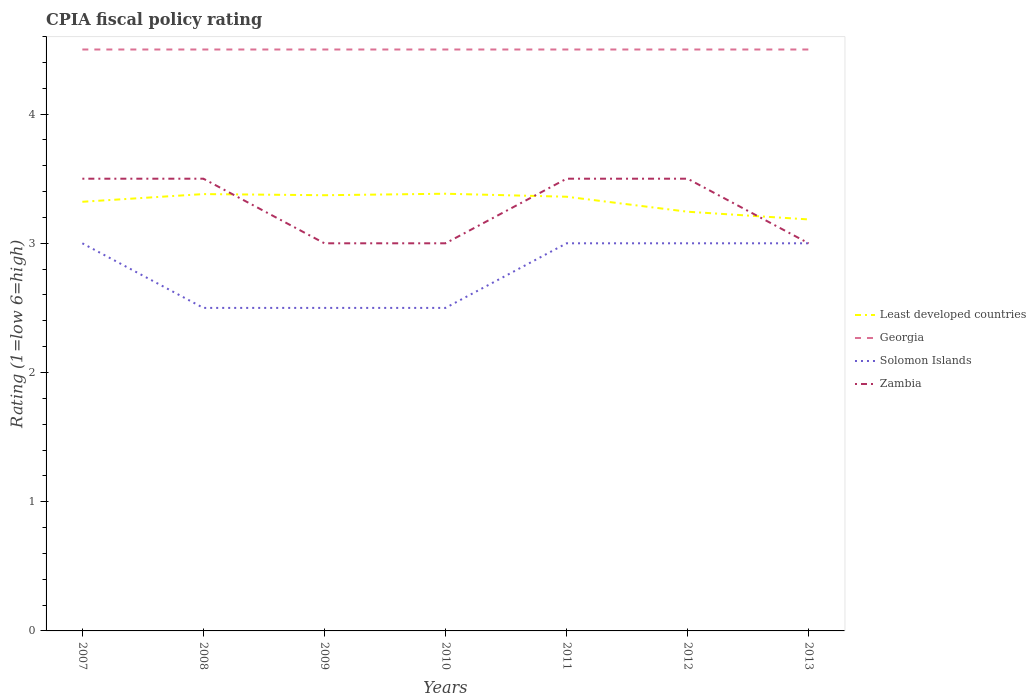How many different coloured lines are there?
Offer a terse response. 4. Does the line corresponding to Zambia intersect with the line corresponding to Georgia?
Make the answer very short. No. Is the number of lines equal to the number of legend labels?
Your answer should be very brief. Yes. Across all years, what is the maximum CPIA rating in Least developed countries?
Ensure brevity in your answer.  3.18. What is the difference between the highest and the second highest CPIA rating in Least developed countries?
Keep it short and to the point. 0.2. Is the CPIA rating in Zambia strictly greater than the CPIA rating in Georgia over the years?
Ensure brevity in your answer.  Yes. How many lines are there?
Provide a short and direct response. 4. What is the difference between two consecutive major ticks on the Y-axis?
Your answer should be very brief. 1. Are the values on the major ticks of Y-axis written in scientific E-notation?
Your answer should be compact. No. Does the graph contain any zero values?
Make the answer very short. No. Does the graph contain grids?
Provide a succinct answer. No. What is the title of the graph?
Your answer should be very brief. CPIA fiscal policy rating. What is the label or title of the Y-axis?
Make the answer very short. Rating (1=low 6=high). What is the Rating (1=low 6=high) of Least developed countries in 2007?
Offer a very short reply. 3.32. What is the Rating (1=low 6=high) of Georgia in 2007?
Your answer should be compact. 4.5. What is the Rating (1=low 6=high) of Solomon Islands in 2007?
Offer a terse response. 3. What is the Rating (1=low 6=high) in Least developed countries in 2008?
Ensure brevity in your answer.  3.38. What is the Rating (1=low 6=high) of Georgia in 2008?
Offer a terse response. 4.5. What is the Rating (1=low 6=high) in Solomon Islands in 2008?
Provide a succinct answer. 2.5. What is the Rating (1=low 6=high) in Zambia in 2008?
Offer a terse response. 3.5. What is the Rating (1=low 6=high) in Least developed countries in 2009?
Your answer should be very brief. 3.37. What is the Rating (1=low 6=high) in Solomon Islands in 2009?
Provide a succinct answer. 2.5. What is the Rating (1=low 6=high) of Least developed countries in 2010?
Give a very brief answer. 3.38. What is the Rating (1=low 6=high) in Georgia in 2010?
Your response must be concise. 4.5. What is the Rating (1=low 6=high) in Zambia in 2010?
Your answer should be compact. 3. What is the Rating (1=low 6=high) of Least developed countries in 2011?
Your answer should be compact. 3.36. What is the Rating (1=low 6=high) of Georgia in 2011?
Your answer should be very brief. 4.5. What is the Rating (1=low 6=high) of Zambia in 2011?
Provide a succinct answer. 3.5. What is the Rating (1=low 6=high) of Least developed countries in 2012?
Provide a succinct answer. 3.24. What is the Rating (1=low 6=high) in Solomon Islands in 2012?
Provide a succinct answer. 3. What is the Rating (1=low 6=high) in Zambia in 2012?
Your response must be concise. 3.5. What is the Rating (1=low 6=high) in Least developed countries in 2013?
Make the answer very short. 3.18. What is the Rating (1=low 6=high) in Zambia in 2013?
Your response must be concise. 3. Across all years, what is the maximum Rating (1=low 6=high) of Least developed countries?
Provide a succinct answer. 3.38. Across all years, what is the maximum Rating (1=low 6=high) of Georgia?
Your response must be concise. 4.5. Across all years, what is the minimum Rating (1=low 6=high) in Least developed countries?
Your answer should be compact. 3.18. Across all years, what is the minimum Rating (1=low 6=high) in Georgia?
Your answer should be compact. 4.5. Across all years, what is the minimum Rating (1=low 6=high) in Zambia?
Make the answer very short. 3. What is the total Rating (1=low 6=high) in Least developed countries in the graph?
Provide a succinct answer. 23.25. What is the total Rating (1=low 6=high) in Georgia in the graph?
Your response must be concise. 31.5. What is the total Rating (1=low 6=high) in Solomon Islands in the graph?
Offer a terse response. 19.5. What is the difference between the Rating (1=low 6=high) of Least developed countries in 2007 and that in 2008?
Keep it short and to the point. -0.06. What is the difference between the Rating (1=low 6=high) in Least developed countries in 2007 and that in 2009?
Make the answer very short. -0.05. What is the difference between the Rating (1=low 6=high) in Georgia in 2007 and that in 2009?
Provide a short and direct response. 0. What is the difference between the Rating (1=low 6=high) in Solomon Islands in 2007 and that in 2009?
Give a very brief answer. 0.5. What is the difference between the Rating (1=low 6=high) of Least developed countries in 2007 and that in 2010?
Make the answer very short. -0.06. What is the difference between the Rating (1=low 6=high) of Solomon Islands in 2007 and that in 2010?
Your response must be concise. 0.5. What is the difference between the Rating (1=low 6=high) of Zambia in 2007 and that in 2010?
Make the answer very short. 0.5. What is the difference between the Rating (1=low 6=high) in Least developed countries in 2007 and that in 2011?
Provide a short and direct response. -0.04. What is the difference between the Rating (1=low 6=high) of Solomon Islands in 2007 and that in 2011?
Your answer should be very brief. 0. What is the difference between the Rating (1=low 6=high) of Zambia in 2007 and that in 2011?
Give a very brief answer. 0. What is the difference between the Rating (1=low 6=high) in Least developed countries in 2007 and that in 2012?
Keep it short and to the point. 0.08. What is the difference between the Rating (1=low 6=high) of Georgia in 2007 and that in 2012?
Provide a succinct answer. 0. What is the difference between the Rating (1=low 6=high) in Solomon Islands in 2007 and that in 2012?
Your answer should be very brief. 0. What is the difference between the Rating (1=low 6=high) in Zambia in 2007 and that in 2012?
Offer a very short reply. 0. What is the difference between the Rating (1=low 6=high) in Least developed countries in 2007 and that in 2013?
Offer a very short reply. 0.14. What is the difference between the Rating (1=low 6=high) of Solomon Islands in 2007 and that in 2013?
Give a very brief answer. 0. What is the difference between the Rating (1=low 6=high) in Least developed countries in 2008 and that in 2009?
Provide a succinct answer. 0.01. What is the difference between the Rating (1=low 6=high) in Solomon Islands in 2008 and that in 2009?
Make the answer very short. 0. What is the difference between the Rating (1=low 6=high) in Least developed countries in 2008 and that in 2010?
Offer a very short reply. -0. What is the difference between the Rating (1=low 6=high) of Georgia in 2008 and that in 2010?
Your answer should be very brief. 0. What is the difference between the Rating (1=low 6=high) of Zambia in 2008 and that in 2010?
Offer a very short reply. 0.5. What is the difference between the Rating (1=low 6=high) in Least developed countries in 2008 and that in 2011?
Offer a very short reply. 0.02. What is the difference between the Rating (1=low 6=high) in Georgia in 2008 and that in 2011?
Give a very brief answer. 0. What is the difference between the Rating (1=low 6=high) in Solomon Islands in 2008 and that in 2011?
Keep it short and to the point. -0.5. What is the difference between the Rating (1=low 6=high) in Least developed countries in 2008 and that in 2012?
Provide a short and direct response. 0.14. What is the difference between the Rating (1=low 6=high) of Solomon Islands in 2008 and that in 2012?
Your answer should be very brief. -0.5. What is the difference between the Rating (1=low 6=high) in Least developed countries in 2008 and that in 2013?
Make the answer very short. 0.2. What is the difference between the Rating (1=low 6=high) in Georgia in 2008 and that in 2013?
Ensure brevity in your answer.  0. What is the difference between the Rating (1=low 6=high) of Least developed countries in 2009 and that in 2010?
Give a very brief answer. -0.01. What is the difference between the Rating (1=low 6=high) of Georgia in 2009 and that in 2010?
Give a very brief answer. 0. What is the difference between the Rating (1=low 6=high) of Zambia in 2009 and that in 2010?
Your answer should be compact. 0. What is the difference between the Rating (1=low 6=high) in Least developed countries in 2009 and that in 2011?
Offer a terse response. 0.01. What is the difference between the Rating (1=low 6=high) of Solomon Islands in 2009 and that in 2011?
Offer a very short reply. -0.5. What is the difference between the Rating (1=low 6=high) of Zambia in 2009 and that in 2011?
Your answer should be very brief. -0.5. What is the difference between the Rating (1=low 6=high) in Least developed countries in 2009 and that in 2012?
Keep it short and to the point. 0.13. What is the difference between the Rating (1=low 6=high) of Georgia in 2009 and that in 2012?
Give a very brief answer. 0. What is the difference between the Rating (1=low 6=high) in Solomon Islands in 2009 and that in 2012?
Your answer should be compact. -0.5. What is the difference between the Rating (1=low 6=high) in Least developed countries in 2009 and that in 2013?
Keep it short and to the point. 0.19. What is the difference between the Rating (1=low 6=high) of Georgia in 2009 and that in 2013?
Give a very brief answer. 0. What is the difference between the Rating (1=low 6=high) of Zambia in 2009 and that in 2013?
Keep it short and to the point. 0. What is the difference between the Rating (1=low 6=high) of Least developed countries in 2010 and that in 2011?
Offer a terse response. 0.02. What is the difference between the Rating (1=low 6=high) of Georgia in 2010 and that in 2011?
Ensure brevity in your answer.  0. What is the difference between the Rating (1=low 6=high) in Least developed countries in 2010 and that in 2012?
Provide a succinct answer. 0.14. What is the difference between the Rating (1=low 6=high) in Zambia in 2010 and that in 2012?
Give a very brief answer. -0.5. What is the difference between the Rating (1=low 6=high) of Least developed countries in 2010 and that in 2013?
Your answer should be very brief. 0.2. What is the difference between the Rating (1=low 6=high) of Georgia in 2010 and that in 2013?
Keep it short and to the point. 0. What is the difference between the Rating (1=low 6=high) in Least developed countries in 2011 and that in 2012?
Keep it short and to the point. 0.12. What is the difference between the Rating (1=low 6=high) in Georgia in 2011 and that in 2012?
Your answer should be very brief. 0. What is the difference between the Rating (1=low 6=high) in Solomon Islands in 2011 and that in 2012?
Provide a succinct answer. 0. What is the difference between the Rating (1=low 6=high) in Least developed countries in 2011 and that in 2013?
Your answer should be compact. 0.18. What is the difference between the Rating (1=low 6=high) in Solomon Islands in 2011 and that in 2013?
Provide a short and direct response. 0. What is the difference between the Rating (1=low 6=high) of Zambia in 2011 and that in 2013?
Your answer should be very brief. 0.5. What is the difference between the Rating (1=low 6=high) in Least developed countries in 2012 and that in 2013?
Make the answer very short. 0.06. What is the difference between the Rating (1=low 6=high) in Georgia in 2012 and that in 2013?
Ensure brevity in your answer.  0. What is the difference between the Rating (1=low 6=high) of Zambia in 2012 and that in 2013?
Provide a succinct answer. 0.5. What is the difference between the Rating (1=low 6=high) in Least developed countries in 2007 and the Rating (1=low 6=high) in Georgia in 2008?
Your answer should be compact. -1.18. What is the difference between the Rating (1=low 6=high) in Least developed countries in 2007 and the Rating (1=low 6=high) in Solomon Islands in 2008?
Offer a very short reply. 0.82. What is the difference between the Rating (1=low 6=high) of Least developed countries in 2007 and the Rating (1=low 6=high) of Zambia in 2008?
Your response must be concise. -0.18. What is the difference between the Rating (1=low 6=high) in Georgia in 2007 and the Rating (1=low 6=high) in Zambia in 2008?
Your answer should be very brief. 1. What is the difference between the Rating (1=low 6=high) of Least developed countries in 2007 and the Rating (1=low 6=high) of Georgia in 2009?
Keep it short and to the point. -1.18. What is the difference between the Rating (1=low 6=high) of Least developed countries in 2007 and the Rating (1=low 6=high) of Solomon Islands in 2009?
Your answer should be compact. 0.82. What is the difference between the Rating (1=low 6=high) in Least developed countries in 2007 and the Rating (1=low 6=high) in Zambia in 2009?
Your response must be concise. 0.32. What is the difference between the Rating (1=low 6=high) of Georgia in 2007 and the Rating (1=low 6=high) of Solomon Islands in 2009?
Provide a succinct answer. 2. What is the difference between the Rating (1=low 6=high) in Georgia in 2007 and the Rating (1=low 6=high) in Zambia in 2009?
Make the answer very short. 1.5. What is the difference between the Rating (1=low 6=high) in Least developed countries in 2007 and the Rating (1=low 6=high) in Georgia in 2010?
Offer a terse response. -1.18. What is the difference between the Rating (1=low 6=high) in Least developed countries in 2007 and the Rating (1=low 6=high) in Solomon Islands in 2010?
Ensure brevity in your answer.  0.82. What is the difference between the Rating (1=low 6=high) in Least developed countries in 2007 and the Rating (1=low 6=high) in Zambia in 2010?
Your answer should be compact. 0.32. What is the difference between the Rating (1=low 6=high) of Georgia in 2007 and the Rating (1=low 6=high) of Solomon Islands in 2010?
Make the answer very short. 2. What is the difference between the Rating (1=low 6=high) in Georgia in 2007 and the Rating (1=low 6=high) in Zambia in 2010?
Provide a short and direct response. 1.5. What is the difference between the Rating (1=low 6=high) of Least developed countries in 2007 and the Rating (1=low 6=high) of Georgia in 2011?
Your response must be concise. -1.18. What is the difference between the Rating (1=low 6=high) in Least developed countries in 2007 and the Rating (1=low 6=high) in Solomon Islands in 2011?
Offer a terse response. 0.32. What is the difference between the Rating (1=low 6=high) of Least developed countries in 2007 and the Rating (1=low 6=high) of Zambia in 2011?
Make the answer very short. -0.18. What is the difference between the Rating (1=low 6=high) of Solomon Islands in 2007 and the Rating (1=low 6=high) of Zambia in 2011?
Provide a succinct answer. -0.5. What is the difference between the Rating (1=low 6=high) in Least developed countries in 2007 and the Rating (1=low 6=high) in Georgia in 2012?
Your answer should be compact. -1.18. What is the difference between the Rating (1=low 6=high) of Least developed countries in 2007 and the Rating (1=low 6=high) of Solomon Islands in 2012?
Provide a short and direct response. 0.32. What is the difference between the Rating (1=low 6=high) in Least developed countries in 2007 and the Rating (1=low 6=high) in Zambia in 2012?
Offer a terse response. -0.18. What is the difference between the Rating (1=low 6=high) of Georgia in 2007 and the Rating (1=low 6=high) of Zambia in 2012?
Give a very brief answer. 1. What is the difference between the Rating (1=low 6=high) of Solomon Islands in 2007 and the Rating (1=low 6=high) of Zambia in 2012?
Your response must be concise. -0.5. What is the difference between the Rating (1=low 6=high) of Least developed countries in 2007 and the Rating (1=low 6=high) of Georgia in 2013?
Make the answer very short. -1.18. What is the difference between the Rating (1=low 6=high) of Least developed countries in 2007 and the Rating (1=low 6=high) of Solomon Islands in 2013?
Your answer should be compact. 0.32. What is the difference between the Rating (1=low 6=high) in Least developed countries in 2007 and the Rating (1=low 6=high) in Zambia in 2013?
Keep it short and to the point. 0.32. What is the difference between the Rating (1=low 6=high) in Georgia in 2007 and the Rating (1=low 6=high) in Solomon Islands in 2013?
Provide a short and direct response. 1.5. What is the difference between the Rating (1=low 6=high) in Least developed countries in 2008 and the Rating (1=low 6=high) in Georgia in 2009?
Your answer should be very brief. -1.12. What is the difference between the Rating (1=low 6=high) in Least developed countries in 2008 and the Rating (1=low 6=high) in Solomon Islands in 2009?
Ensure brevity in your answer.  0.88. What is the difference between the Rating (1=low 6=high) in Least developed countries in 2008 and the Rating (1=low 6=high) in Zambia in 2009?
Offer a terse response. 0.38. What is the difference between the Rating (1=low 6=high) in Georgia in 2008 and the Rating (1=low 6=high) in Solomon Islands in 2009?
Ensure brevity in your answer.  2. What is the difference between the Rating (1=low 6=high) of Solomon Islands in 2008 and the Rating (1=low 6=high) of Zambia in 2009?
Make the answer very short. -0.5. What is the difference between the Rating (1=low 6=high) in Least developed countries in 2008 and the Rating (1=low 6=high) in Georgia in 2010?
Your answer should be compact. -1.12. What is the difference between the Rating (1=low 6=high) of Least developed countries in 2008 and the Rating (1=low 6=high) of Solomon Islands in 2010?
Your answer should be compact. 0.88. What is the difference between the Rating (1=low 6=high) of Least developed countries in 2008 and the Rating (1=low 6=high) of Zambia in 2010?
Ensure brevity in your answer.  0.38. What is the difference between the Rating (1=low 6=high) in Georgia in 2008 and the Rating (1=low 6=high) in Solomon Islands in 2010?
Ensure brevity in your answer.  2. What is the difference between the Rating (1=low 6=high) of Least developed countries in 2008 and the Rating (1=low 6=high) of Georgia in 2011?
Provide a succinct answer. -1.12. What is the difference between the Rating (1=low 6=high) of Least developed countries in 2008 and the Rating (1=low 6=high) of Solomon Islands in 2011?
Make the answer very short. 0.38. What is the difference between the Rating (1=low 6=high) of Least developed countries in 2008 and the Rating (1=low 6=high) of Zambia in 2011?
Provide a succinct answer. -0.12. What is the difference between the Rating (1=low 6=high) of Georgia in 2008 and the Rating (1=low 6=high) of Solomon Islands in 2011?
Offer a terse response. 1.5. What is the difference between the Rating (1=low 6=high) in Solomon Islands in 2008 and the Rating (1=low 6=high) in Zambia in 2011?
Your answer should be compact. -1. What is the difference between the Rating (1=low 6=high) in Least developed countries in 2008 and the Rating (1=low 6=high) in Georgia in 2012?
Provide a short and direct response. -1.12. What is the difference between the Rating (1=low 6=high) of Least developed countries in 2008 and the Rating (1=low 6=high) of Solomon Islands in 2012?
Give a very brief answer. 0.38. What is the difference between the Rating (1=low 6=high) in Least developed countries in 2008 and the Rating (1=low 6=high) in Zambia in 2012?
Provide a succinct answer. -0.12. What is the difference between the Rating (1=low 6=high) of Solomon Islands in 2008 and the Rating (1=low 6=high) of Zambia in 2012?
Offer a very short reply. -1. What is the difference between the Rating (1=low 6=high) of Least developed countries in 2008 and the Rating (1=low 6=high) of Georgia in 2013?
Your answer should be very brief. -1.12. What is the difference between the Rating (1=low 6=high) in Least developed countries in 2008 and the Rating (1=low 6=high) in Solomon Islands in 2013?
Provide a succinct answer. 0.38. What is the difference between the Rating (1=low 6=high) of Least developed countries in 2008 and the Rating (1=low 6=high) of Zambia in 2013?
Your answer should be compact. 0.38. What is the difference between the Rating (1=low 6=high) in Georgia in 2008 and the Rating (1=low 6=high) in Solomon Islands in 2013?
Keep it short and to the point. 1.5. What is the difference between the Rating (1=low 6=high) of Solomon Islands in 2008 and the Rating (1=low 6=high) of Zambia in 2013?
Provide a short and direct response. -0.5. What is the difference between the Rating (1=low 6=high) of Least developed countries in 2009 and the Rating (1=low 6=high) of Georgia in 2010?
Keep it short and to the point. -1.13. What is the difference between the Rating (1=low 6=high) of Least developed countries in 2009 and the Rating (1=low 6=high) of Solomon Islands in 2010?
Offer a terse response. 0.87. What is the difference between the Rating (1=low 6=high) in Least developed countries in 2009 and the Rating (1=low 6=high) in Zambia in 2010?
Your answer should be very brief. 0.37. What is the difference between the Rating (1=low 6=high) of Georgia in 2009 and the Rating (1=low 6=high) of Solomon Islands in 2010?
Your answer should be very brief. 2. What is the difference between the Rating (1=low 6=high) in Solomon Islands in 2009 and the Rating (1=low 6=high) in Zambia in 2010?
Offer a very short reply. -0.5. What is the difference between the Rating (1=low 6=high) of Least developed countries in 2009 and the Rating (1=low 6=high) of Georgia in 2011?
Your answer should be very brief. -1.13. What is the difference between the Rating (1=low 6=high) of Least developed countries in 2009 and the Rating (1=low 6=high) of Solomon Islands in 2011?
Ensure brevity in your answer.  0.37. What is the difference between the Rating (1=low 6=high) in Least developed countries in 2009 and the Rating (1=low 6=high) in Zambia in 2011?
Your answer should be compact. -0.13. What is the difference between the Rating (1=low 6=high) of Least developed countries in 2009 and the Rating (1=low 6=high) of Georgia in 2012?
Offer a very short reply. -1.13. What is the difference between the Rating (1=low 6=high) of Least developed countries in 2009 and the Rating (1=low 6=high) of Solomon Islands in 2012?
Offer a very short reply. 0.37. What is the difference between the Rating (1=low 6=high) in Least developed countries in 2009 and the Rating (1=low 6=high) in Zambia in 2012?
Ensure brevity in your answer.  -0.13. What is the difference between the Rating (1=low 6=high) in Georgia in 2009 and the Rating (1=low 6=high) in Solomon Islands in 2012?
Make the answer very short. 1.5. What is the difference between the Rating (1=low 6=high) of Solomon Islands in 2009 and the Rating (1=low 6=high) of Zambia in 2012?
Offer a very short reply. -1. What is the difference between the Rating (1=low 6=high) in Least developed countries in 2009 and the Rating (1=low 6=high) in Georgia in 2013?
Provide a short and direct response. -1.13. What is the difference between the Rating (1=low 6=high) of Least developed countries in 2009 and the Rating (1=low 6=high) of Solomon Islands in 2013?
Provide a succinct answer. 0.37. What is the difference between the Rating (1=low 6=high) in Least developed countries in 2009 and the Rating (1=low 6=high) in Zambia in 2013?
Provide a succinct answer. 0.37. What is the difference between the Rating (1=low 6=high) in Georgia in 2009 and the Rating (1=low 6=high) in Zambia in 2013?
Provide a succinct answer. 1.5. What is the difference between the Rating (1=low 6=high) in Least developed countries in 2010 and the Rating (1=low 6=high) in Georgia in 2011?
Your answer should be very brief. -1.12. What is the difference between the Rating (1=low 6=high) of Least developed countries in 2010 and the Rating (1=low 6=high) of Solomon Islands in 2011?
Your response must be concise. 0.38. What is the difference between the Rating (1=low 6=high) in Least developed countries in 2010 and the Rating (1=low 6=high) in Zambia in 2011?
Ensure brevity in your answer.  -0.12. What is the difference between the Rating (1=low 6=high) of Solomon Islands in 2010 and the Rating (1=low 6=high) of Zambia in 2011?
Your answer should be compact. -1. What is the difference between the Rating (1=low 6=high) of Least developed countries in 2010 and the Rating (1=low 6=high) of Georgia in 2012?
Provide a short and direct response. -1.12. What is the difference between the Rating (1=low 6=high) of Least developed countries in 2010 and the Rating (1=low 6=high) of Solomon Islands in 2012?
Your answer should be compact. 0.38. What is the difference between the Rating (1=low 6=high) in Least developed countries in 2010 and the Rating (1=low 6=high) in Zambia in 2012?
Provide a short and direct response. -0.12. What is the difference between the Rating (1=low 6=high) in Least developed countries in 2010 and the Rating (1=low 6=high) in Georgia in 2013?
Your answer should be compact. -1.12. What is the difference between the Rating (1=low 6=high) in Least developed countries in 2010 and the Rating (1=low 6=high) in Solomon Islands in 2013?
Offer a very short reply. 0.38. What is the difference between the Rating (1=low 6=high) in Least developed countries in 2010 and the Rating (1=low 6=high) in Zambia in 2013?
Offer a terse response. 0.38. What is the difference between the Rating (1=low 6=high) of Georgia in 2010 and the Rating (1=low 6=high) of Zambia in 2013?
Provide a short and direct response. 1.5. What is the difference between the Rating (1=low 6=high) in Least developed countries in 2011 and the Rating (1=low 6=high) in Georgia in 2012?
Provide a succinct answer. -1.14. What is the difference between the Rating (1=low 6=high) in Least developed countries in 2011 and the Rating (1=low 6=high) in Solomon Islands in 2012?
Your answer should be very brief. 0.36. What is the difference between the Rating (1=low 6=high) of Least developed countries in 2011 and the Rating (1=low 6=high) of Zambia in 2012?
Your answer should be very brief. -0.14. What is the difference between the Rating (1=low 6=high) of Least developed countries in 2011 and the Rating (1=low 6=high) of Georgia in 2013?
Give a very brief answer. -1.14. What is the difference between the Rating (1=low 6=high) in Least developed countries in 2011 and the Rating (1=low 6=high) in Solomon Islands in 2013?
Keep it short and to the point. 0.36. What is the difference between the Rating (1=low 6=high) in Least developed countries in 2011 and the Rating (1=low 6=high) in Zambia in 2013?
Provide a short and direct response. 0.36. What is the difference between the Rating (1=low 6=high) of Georgia in 2011 and the Rating (1=low 6=high) of Zambia in 2013?
Ensure brevity in your answer.  1.5. What is the difference between the Rating (1=low 6=high) of Least developed countries in 2012 and the Rating (1=low 6=high) of Georgia in 2013?
Offer a very short reply. -1.26. What is the difference between the Rating (1=low 6=high) of Least developed countries in 2012 and the Rating (1=low 6=high) of Solomon Islands in 2013?
Make the answer very short. 0.24. What is the difference between the Rating (1=low 6=high) in Least developed countries in 2012 and the Rating (1=low 6=high) in Zambia in 2013?
Ensure brevity in your answer.  0.24. What is the average Rating (1=low 6=high) of Least developed countries per year?
Provide a succinct answer. 3.32. What is the average Rating (1=low 6=high) of Georgia per year?
Keep it short and to the point. 4.5. What is the average Rating (1=low 6=high) in Solomon Islands per year?
Your answer should be very brief. 2.79. What is the average Rating (1=low 6=high) of Zambia per year?
Your response must be concise. 3.29. In the year 2007, what is the difference between the Rating (1=low 6=high) of Least developed countries and Rating (1=low 6=high) of Georgia?
Your answer should be very brief. -1.18. In the year 2007, what is the difference between the Rating (1=low 6=high) of Least developed countries and Rating (1=low 6=high) of Solomon Islands?
Provide a succinct answer. 0.32. In the year 2007, what is the difference between the Rating (1=low 6=high) in Least developed countries and Rating (1=low 6=high) in Zambia?
Make the answer very short. -0.18. In the year 2007, what is the difference between the Rating (1=low 6=high) in Georgia and Rating (1=low 6=high) in Solomon Islands?
Provide a succinct answer. 1.5. In the year 2008, what is the difference between the Rating (1=low 6=high) in Least developed countries and Rating (1=low 6=high) in Georgia?
Offer a very short reply. -1.12. In the year 2008, what is the difference between the Rating (1=low 6=high) in Least developed countries and Rating (1=low 6=high) in Solomon Islands?
Provide a succinct answer. 0.88. In the year 2008, what is the difference between the Rating (1=low 6=high) in Least developed countries and Rating (1=low 6=high) in Zambia?
Your response must be concise. -0.12. In the year 2008, what is the difference between the Rating (1=low 6=high) of Solomon Islands and Rating (1=low 6=high) of Zambia?
Provide a succinct answer. -1. In the year 2009, what is the difference between the Rating (1=low 6=high) of Least developed countries and Rating (1=low 6=high) of Georgia?
Keep it short and to the point. -1.13. In the year 2009, what is the difference between the Rating (1=low 6=high) of Least developed countries and Rating (1=low 6=high) of Solomon Islands?
Give a very brief answer. 0.87. In the year 2009, what is the difference between the Rating (1=low 6=high) of Least developed countries and Rating (1=low 6=high) of Zambia?
Your answer should be very brief. 0.37. In the year 2010, what is the difference between the Rating (1=low 6=high) in Least developed countries and Rating (1=low 6=high) in Georgia?
Your answer should be very brief. -1.12. In the year 2010, what is the difference between the Rating (1=low 6=high) in Least developed countries and Rating (1=low 6=high) in Solomon Islands?
Ensure brevity in your answer.  0.88. In the year 2010, what is the difference between the Rating (1=low 6=high) of Least developed countries and Rating (1=low 6=high) of Zambia?
Your answer should be very brief. 0.38. In the year 2010, what is the difference between the Rating (1=low 6=high) of Georgia and Rating (1=low 6=high) of Zambia?
Your answer should be compact. 1.5. In the year 2010, what is the difference between the Rating (1=low 6=high) of Solomon Islands and Rating (1=low 6=high) of Zambia?
Your answer should be very brief. -0.5. In the year 2011, what is the difference between the Rating (1=low 6=high) of Least developed countries and Rating (1=low 6=high) of Georgia?
Provide a short and direct response. -1.14. In the year 2011, what is the difference between the Rating (1=low 6=high) of Least developed countries and Rating (1=low 6=high) of Solomon Islands?
Your answer should be very brief. 0.36. In the year 2011, what is the difference between the Rating (1=low 6=high) in Least developed countries and Rating (1=low 6=high) in Zambia?
Make the answer very short. -0.14. In the year 2011, what is the difference between the Rating (1=low 6=high) in Solomon Islands and Rating (1=low 6=high) in Zambia?
Keep it short and to the point. -0.5. In the year 2012, what is the difference between the Rating (1=low 6=high) in Least developed countries and Rating (1=low 6=high) in Georgia?
Ensure brevity in your answer.  -1.26. In the year 2012, what is the difference between the Rating (1=low 6=high) of Least developed countries and Rating (1=low 6=high) of Solomon Islands?
Ensure brevity in your answer.  0.24. In the year 2012, what is the difference between the Rating (1=low 6=high) of Least developed countries and Rating (1=low 6=high) of Zambia?
Provide a short and direct response. -0.26. In the year 2012, what is the difference between the Rating (1=low 6=high) of Georgia and Rating (1=low 6=high) of Solomon Islands?
Provide a succinct answer. 1.5. In the year 2012, what is the difference between the Rating (1=low 6=high) of Solomon Islands and Rating (1=low 6=high) of Zambia?
Provide a short and direct response. -0.5. In the year 2013, what is the difference between the Rating (1=low 6=high) in Least developed countries and Rating (1=low 6=high) in Georgia?
Ensure brevity in your answer.  -1.32. In the year 2013, what is the difference between the Rating (1=low 6=high) of Least developed countries and Rating (1=low 6=high) of Solomon Islands?
Your answer should be compact. 0.18. In the year 2013, what is the difference between the Rating (1=low 6=high) in Least developed countries and Rating (1=low 6=high) in Zambia?
Your answer should be compact. 0.18. In the year 2013, what is the difference between the Rating (1=low 6=high) in Georgia and Rating (1=low 6=high) in Solomon Islands?
Offer a terse response. 1.5. In the year 2013, what is the difference between the Rating (1=low 6=high) in Georgia and Rating (1=low 6=high) in Zambia?
Keep it short and to the point. 1.5. What is the ratio of the Rating (1=low 6=high) in Least developed countries in 2007 to that in 2008?
Give a very brief answer. 0.98. What is the ratio of the Rating (1=low 6=high) in Solomon Islands in 2007 to that in 2008?
Offer a very short reply. 1.2. What is the ratio of the Rating (1=low 6=high) of Zambia in 2007 to that in 2008?
Give a very brief answer. 1. What is the ratio of the Rating (1=low 6=high) of Georgia in 2007 to that in 2009?
Your response must be concise. 1. What is the ratio of the Rating (1=low 6=high) in Zambia in 2007 to that in 2009?
Ensure brevity in your answer.  1.17. What is the ratio of the Rating (1=low 6=high) in Least developed countries in 2007 to that in 2010?
Your answer should be very brief. 0.98. What is the ratio of the Rating (1=low 6=high) of Georgia in 2007 to that in 2010?
Ensure brevity in your answer.  1. What is the ratio of the Rating (1=low 6=high) of Solomon Islands in 2007 to that in 2010?
Your answer should be very brief. 1.2. What is the ratio of the Rating (1=low 6=high) in Zambia in 2007 to that in 2010?
Your answer should be very brief. 1.17. What is the ratio of the Rating (1=low 6=high) of Least developed countries in 2007 to that in 2011?
Provide a short and direct response. 0.99. What is the ratio of the Rating (1=low 6=high) of Georgia in 2007 to that in 2011?
Your response must be concise. 1. What is the ratio of the Rating (1=low 6=high) of Solomon Islands in 2007 to that in 2011?
Your answer should be compact. 1. What is the ratio of the Rating (1=low 6=high) of Zambia in 2007 to that in 2011?
Make the answer very short. 1. What is the ratio of the Rating (1=low 6=high) in Least developed countries in 2007 to that in 2012?
Provide a short and direct response. 1.02. What is the ratio of the Rating (1=low 6=high) in Georgia in 2007 to that in 2012?
Provide a short and direct response. 1. What is the ratio of the Rating (1=low 6=high) in Solomon Islands in 2007 to that in 2012?
Offer a very short reply. 1. What is the ratio of the Rating (1=low 6=high) in Zambia in 2007 to that in 2012?
Ensure brevity in your answer.  1. What is the ratio of the Rating (1=low 6=high) in Least developed countries in 2007 to that in 2013?
Your answer should be compact. 1.04. What is the ratio of the Rating (1=low 6=high) in Zambia in 2007 to that in 2013?
Your answer should be compact. 1.17. What is the ratio of the Rating (1=low 6=high) of Least developed countries in 2008 to that in 2009?
Keep it short and to the point. 1. What is the ratio of the Rating (1=low 6=high) of Georgia in 2008 to that in 2009?
Provide a succinct answer. 1. What is the ratio of the Rating (1=low 6=high) in Solomon Islands in 2008 to that in 2009?
Keep it short and to the point. 1. What is the ratio of the Rating (1=low 6=high) of Zambia in 2008 to that in 2010?
Your response must be concise. 1.17. What is the ratio of the Rating (1=low 6=high) of Least developed countries in 2008 to that in 2011?
Your response must be concise. 1.01. What is the ratio of the Rating (1=low 6=high) of Georgia in 2008 to that in 2011?
Your answer should be compact. 1. What is the ratio of the Rating (1=low 6=high) in Solomon Islands in 2008 to that in 2011?
Your response must be concise. 0.83. What is the ratio of the Rating (1=low 6=high) of Zambia in 2008 to that in 2011?
Provide a short and direct response. 1. What is the ratio of the Rating (1=low 6=high) of Least developed countries in 2008 to that in 2012?
Keep it short and to the point. 1.04. What is the ratio of the Rating (1=low 6=high) of Least developed countries in 2008 to that in 2013?
Offer a very short reply. 1.06. What is the ratio of the Rating (1=low 6=high) of Zambia in 2008 to that in 2013?
Offer a very short reply. 1.17. What is the ratio of the Rating (1=low 6=high) of Zambia in 2009 to that in 2010?
Give a very brief answer. 1. What is the ratio of the Rating (1=low 6=high) in Least developed countries in 2009 to that in 2011?
Keep it short and to the point. 1. What is the ratio of the Rating (1=low 6=high) in Georgia in 2009 to that in 2011?
Give a very brief answer. 1. What is the ratio of the Rating (1=low 6=high) of Least developed countries in 2009 to that in 2012?
Give a very brief answer. 1.04. What is the ratio of the Rating (1=low 6=high) of Solomon Islands in 2009 to that in 2012?
Offer a terse response. 0.83. What is the ratio of the Rating (1=low 6=high) of Zambia in 2009 to that in 2012?
Your response must be concise. 0.86. What is the ratio of the Rating (1=low 6=high) in Least developed countries in 2009 to that in 2013?
Make the answer very short. 1.06. What is the ratio of the Rating (1=low 6=high) of Solomon Islands in 2009 to that in 2013?
Provide a succinct answer. 0.83. What is the ratio of the Rating (1=low 6=high) of Least developed countries in 2010 to that in 2011?
Provide a short and direct response. 1.01. What is the ratio of the Rating (1=low 6=high) of Solomon Islands in 2010 to that in 2011?
Offer a terse response. 0.83. What is the ratio of the Rating (1=low 6=high) of Zambia in 2010 to that in 2011?
Provide a short and direct response. 0.86. What is the ratio of the Rating (1=low 6=high) in Least developed countries in 2010 to that in 2012?
Your answer should be very brief. 1.04. What is the ratio of the Rating (1=low 6=high) of Zambia in 2010 to that in 2012?
Your answer should be very brief. 0.86. What is the ratio of the Rating (1=low 6=high) in Least developed countries in 2010 to that in 2013?
Keep it short and to the point. 1.06. What is the ratio of the Rating (1=low 6=high) in Georgia in 2010 to that in 2013?
Provide a short and direct response. 1. What is the ratio of the Rating (1=low 6=high) in Zambia in 2010 to that in 2013?
Give a very brief answer. 1. What is the ratio of the Rating (1=low 6=high) in Least developed countries in 2011 to that in 2012?
Keep it short and to the point. 1.04. What is the ratio of the Rating (1=low 6=high) in Zambia in 2011 to that in 2012?
Your answer should be compact. 1. What is the ratio of the Rating (1=low 6=high) in Least developed countries in 2011 to that in 2013?
Ensure brevity in your answer.  1.06. What is the ratio of the Rating (1=low 6=high) of Georgia in 2011 to that in 2013?
Give a very brief answer. 1. What is the ratio of the Rating (1=low 6=high) in Solomon Islands in 2011 to that in 2013?
Provide a short and direct response. 1. What is the ratio of the Rating (1=low 6=high) in Zambia in 2011 to that in 2013?
Your answer should be very brief. 1.17. What is the ratio of the Rating (1=low 6=high) in Least developed countries in 2012 to that in 2013?
Your response must be concise. 1.02. What is the ratio of the Rating (1=low 6=high) of Georgia in 2012 to that in 2013?
Offer a very short reply. 1. What is the ratio of the Rating (1=low 6=high) in Zambia in 2012 to that in 2013?
Ensure brevity in your answer.  1.17. What is the difference between the highest and the second highest Rating (1=low 6=high) in Least developed countries?
Your response must be concise. 0. What is the difference between the highest and the second highest Rating (1=low 6=high) in Zambia?
Ensure brevity in your answer.  0. What is the difference between the highest and the lowest Rating (1=low 6=high) in Least developed countries?
Your answer should be compact. 0.2. What is the difference between the highest and the lowest Rating (1=low 6=high) of Georgia?
Your answer should be compact. 0. What is the difference between the highest and the lowest Rating (1=low 6=high) of Solomon Islands?
Offer a terse response. 0.5. 